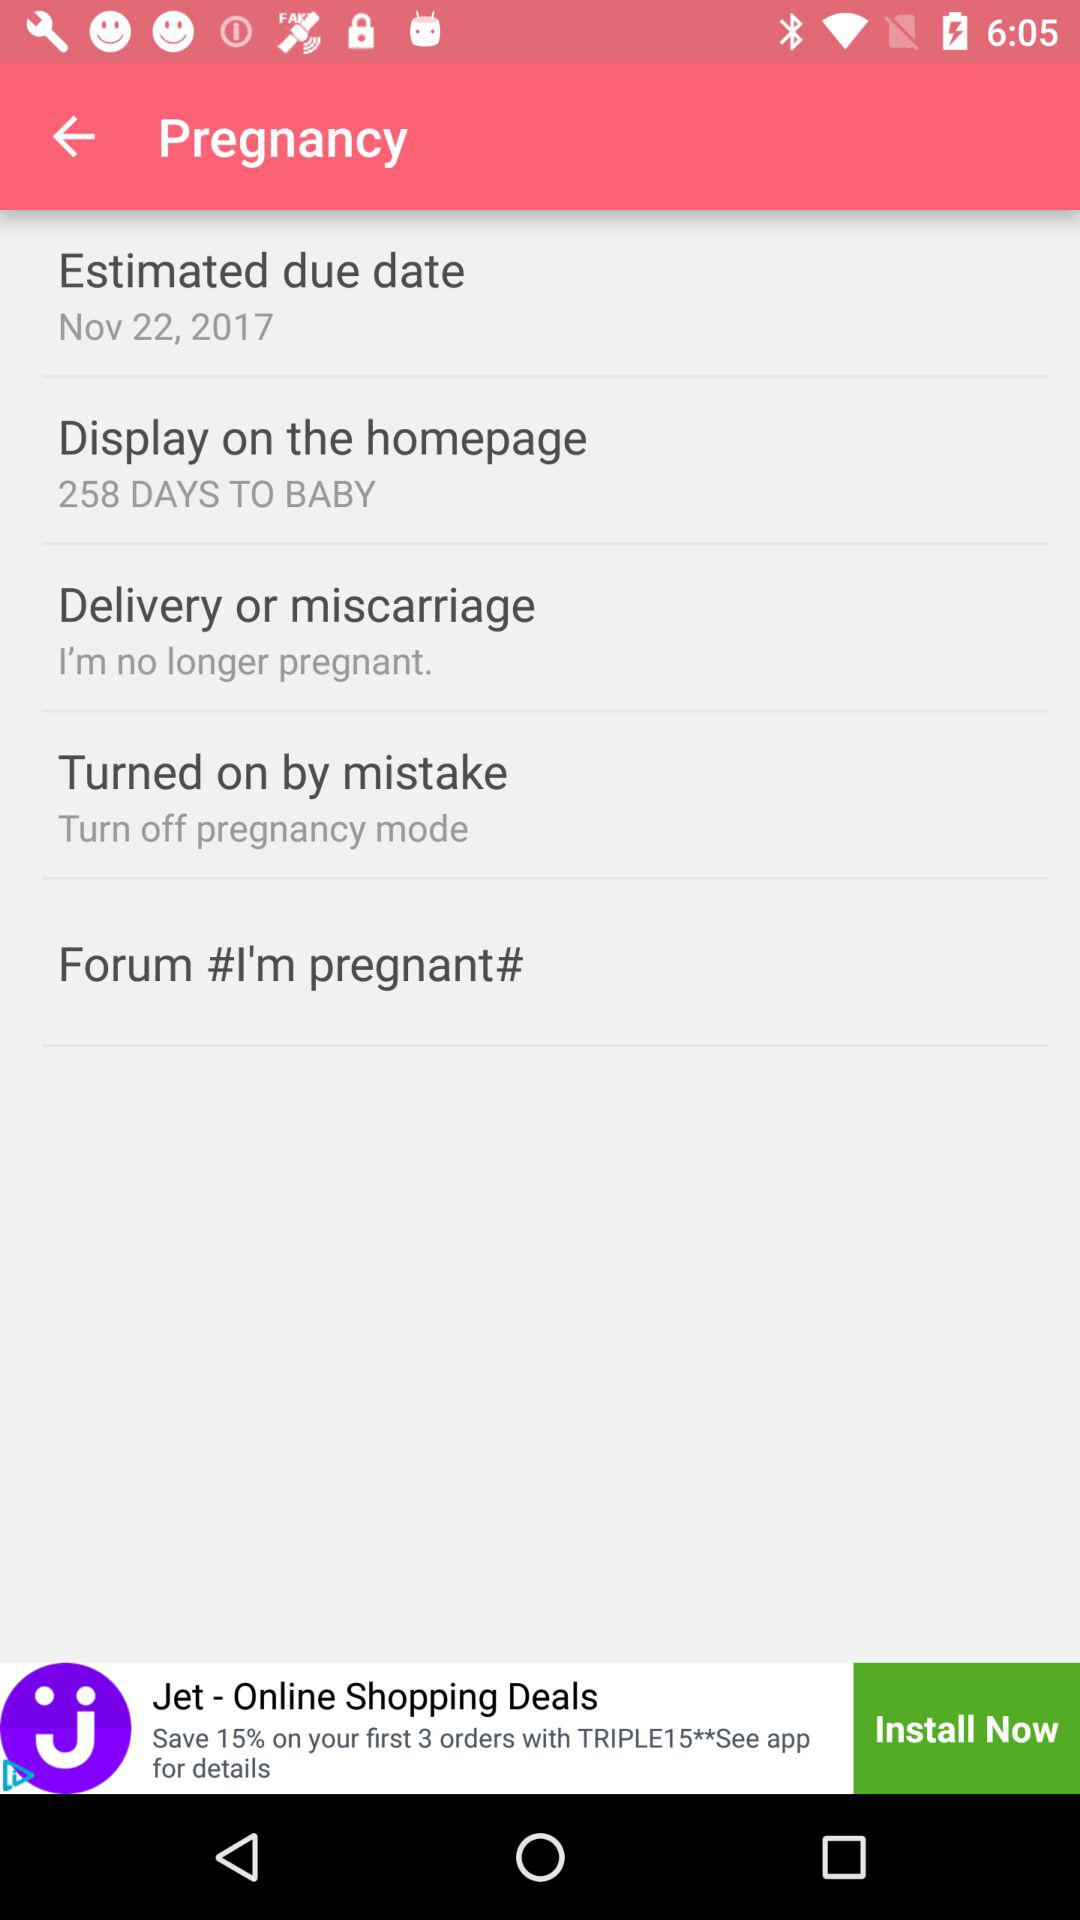Who is pregnant?
When the provided information is insufficient, respond with <no answer>. <no answer> 